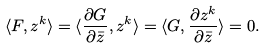Convert formula to latex. <formula><loc_0><loc_0><loc_500><loc_500>\langle F , z ^ { k } \rangle = \langle \frac { \partial G } { \partial \bar { z } } , z ^ { k } \rangle = \langle G , \frac { \partial z ^ { k } } { \partial \bar { z } } \rangle = 0 .</formula> 